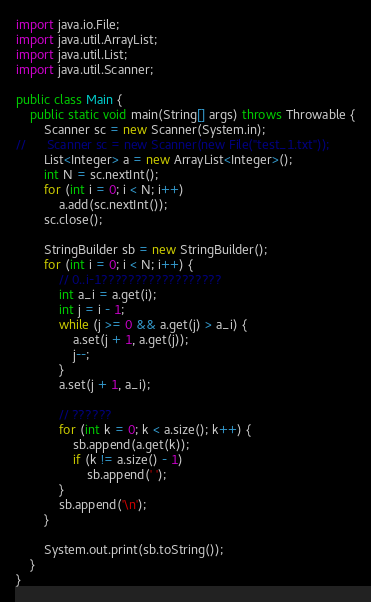Convert code to text. <code><loc_0><loc_0><loc_500><loc_500><_Java_>import java.io.File;
import java.util.ArrayList;
import java.util.List;
import java.util.Scanner;

public class Main {
	public static void main(String[] args) throws Throwable {
		Scanner sc = new Scanner(System.in);
//		Scanner sc = new Scanner(new File("test_1.txt"));
		List<Integer> a = new ArrayList<Integer>();
		int N = sc.nextInt();
		for (int i = 0; i < N; i++)
			a.add(sc.nextInt());
		sc.close();
		
		StringBuilder sb = new StringBuilder();
		for (int i = 0; i < N; i++) {
			// 0..i-1??????????????????
			int a_i = a.get(i);
			int j = i - 1;
			while (j >= 0 && a.get(j) > a_i) {
				a.set(j + 1, a.get(j));
				j--;
			}
			a.set(j + 1, a_i);
			
			// ??????
			for (int k = 0; k < a.size(); k++) {
				sb.append(a.get(k));
				if (k != a.size() - 1)
					sb.append(' ');
			}
			sb.append('\n');
		}
		
		System.out.print(sb.toString());
	}
}</code> 